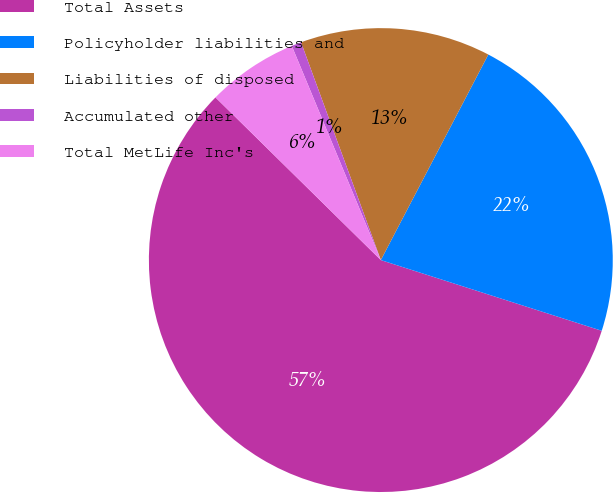<chart> <loc_0><loc_0><loc_500><loc_500><pie_chart><fcel>Total Assets<fcel>Policyholder liabilities and<fcel>Liabilities of disposed<fcel>Accumulated other<fcel>Total MetLife Inc's<nl><fcel>57.44%<fcel>22.26%<fcel>13.26%<fcel>0.68%<fcel>6.36%<nl></chart> 